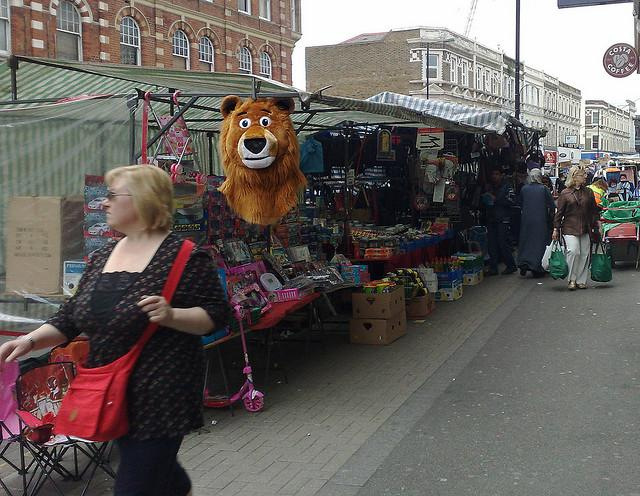Why are there stalls with products outside? Please explain your reasoning. to sell. The stands are set up in a public place with merchandise on display. 